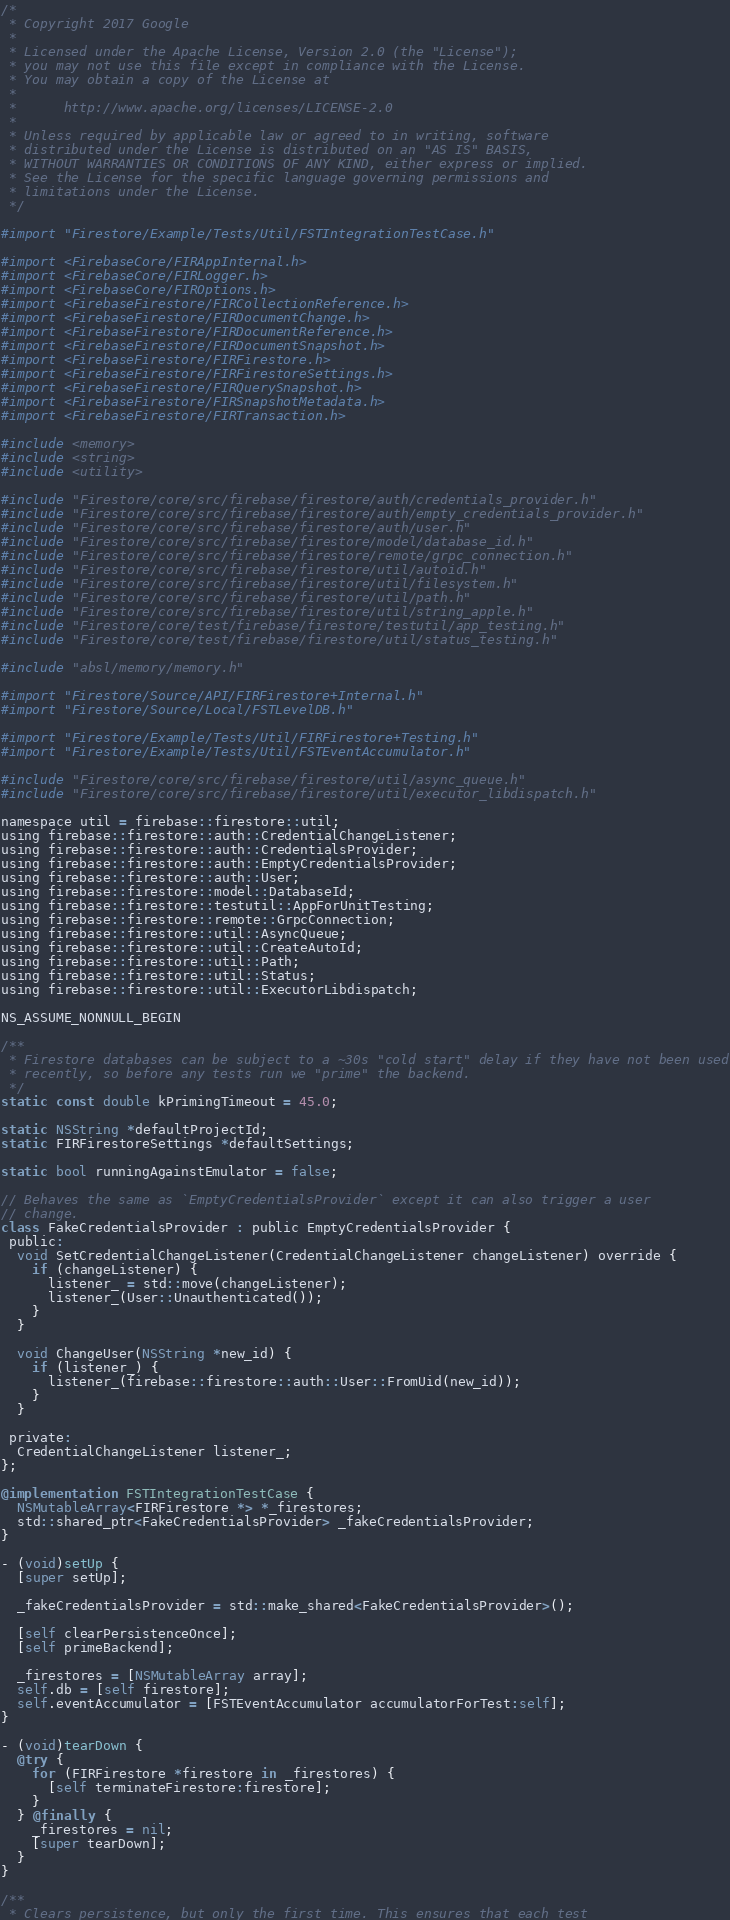<code> <loc_0><loc_0><loc_500><loc_500><_ObjectiveC_>/*
 * Copyright 2017 Google
 *
 * Licensed under the Apache License, Version 2.0 (the "License");
 * you may not use this file except in compliance with the License.
 * You may obtain a copy of the License at
 *
 *      http://www.apache.org/licenses/LICENSE-2.0
 *
 * Unless required by applicable law or agreed to in writing, software
 * distributed under the License is distributed on an "AS IS" BASIS,
 * WITHOUT WARRANTIES OR CONDITIONS OF ANY KIND, either express or implied.
 * See the License for the specific language governing permissions and
 * limitations under the License.
 */

#import "Firestore/Example/Tests/Util/FSTIntegrationTestCase.h"

#import <FirebaseCore/FIRAppInternal.h>
#import <FirebaseCore/FIRLogger.h>
#import <FirebaseCore/FIROptions.h>
#import <FirebaseFirestore/FIRCollectionReference.h>
#import <FirebaseFirestore/FIRDocumentChange.h>
#import <FirebaseFirestore/FIRDocumentReference.h>
#import <FirebaseFirestore/FIRDocumentSnapshot.h>
#import <FirebaseFirestore/FIRFirestore.h>
#import <FirebaseFirestore/FIRFirestoreSettings.h>
#import <FirebaseFirestore/FIRQuerySnapshot.h>
#import <FirebaseFirestore/FIRSnapshotMetadata.h>
#import <FirebaseFirestore/FIRTransaction.h>

#include <memory>
#include <string>
#include <utility>

#include "Firestore/core/src/firebase/firestore/auth/credentials_provider.h"
#include "Firestore/core/src/firebase/firestore/auth/empty_credentials_provider.h"
#include "Firestore/core/src/firebase/firestore/auth/user.h"
#include "Firestore/core/src/firebase/firestore/model/database_id.h"
#include "Firestore/core/src/firebase/firestore/remote/grpc_connection.h"
#include "Firestore/core/src/firebase/firestore/util/autoid.h"
#include "Firestore/core/src/firebase/firestore/util/filesystem.h"
#include "Firestore/core/src/firebase/firestore/util/path.h"
#include "Firestore/core/src/firebase/firestore/util/string_apple.h"
#include "Firestore/core/test/firebase/firestore/testutil/app_testing.h"
#include "Firestore/core/test/firebase/firestore/util/status_testing.h"

#include "absl/memory/memory.h"

#import "Firestore/Source/API/FIRFirestore+Internal.h"
#import "Firestore/Source/Local/FSTLevelDB.h"

#import "Firestore/Example/Tests/Util/FIRFirestore+Testing.h"
#import "Firestore/Example/Tests/Util/FSTEventAccumulator.h"

#include "Firestore/core/src/firebase/firestore/util/async_queue.h"
#include "Firestore/core/src/firebase/firestore/util/executor_libdispatch.h"

namespace util = firebase::firestore::util;
using firebase::firestore::auth::CredentialChangeListener;
using firebase::firestore::auth::CredentialsProvider;
using firebase::firestore::auth::EmptyCredentialsProvider;
using firebase::firestore::auth::User;
using firebase::firestore::model::DatabaseId;
using firebase::firestore::testutil::AppForUnitTesting;
using firebase::firestore::remote::GrpcConnection;
using firebase::firestore::util::AsyncQueue;
using firebase::firestore::util::CreateAutoId;
using firebase::firestore::util::Path;
using firebase::firestore::util::Status;
using firebase::firestore::util::ExecutorLibdispatch;

NS_ASSUME_NONNULL_BEGIN

/**
 * Firestore databases can be subject to a ~30s "cold start" delay if they have not been used
 * recently, so before any tests run we "prime" the backend.
 */
static const double kPrimingTimeout = 45.0;

static NSString *defaultProjectId;
static FIRFirestoreSettings *defaultSettings;

static bool runningAgainstEmulator = false;

// Behaves the same as `EmptyCredentialsProvider` except it can also trigger a user
// change.
class FakeCredentialsProvider : public EmptyCredentialsProvider {
 public:
  void SetCredentialChangeListener(CredentialChangeListener changeListener) override {
    if (changeListener) {
      listener_ = std::move(changeListener);
      listener_(User::Unauthenticated());
    }
  }

  void ChangeUser(NSString *new_id) {
    if (listener_) {
      listener_(firebase::firestore::auth::User::FromUid(new_id));
    }
  }

 private:
  CredentialChangeListener listener_;
};

@implementation FSTIntegrationTestCase {
  NSMutableArray<FIRFirestore *> *_firestores;
  std::shared_ptr<FakeCredentialsProvider> _fakeCredentialsProvider;
}

- (void)setUp {
  [super setUp];

  _fakeCredentialsProvider = std::make_shared<FakeCredentialsProvider>();

  [self clearPersistenceOnce];
  [self primeBackend];

  _firestores = [NSMutableArray array];
  self.db = [self firestore];
  self.eventAccumulator = [FSTEventAccumulator accumulatorForTest:self];
}

- (void)tearDown {
  @try {
    for (FIRFirestore *firestore in _firestores) {
      [self terminateFirestore:firestore];
    }
  } @finally {
    _firestores = nil;
    [super tearDown];
  }
}

/**
 * Clears persistence, but only the first time. This ensures that each test</code> 